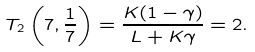Convert formula to latex. <formula><loc_0><loc_0><loc_500><loc_500>T _ { 2 } \left ( 7 , \frac { 1 } { 7 } \right ) = \frac { K ( 1 - \gamma ) } { L + K \gamma } = 2 .</formula> 